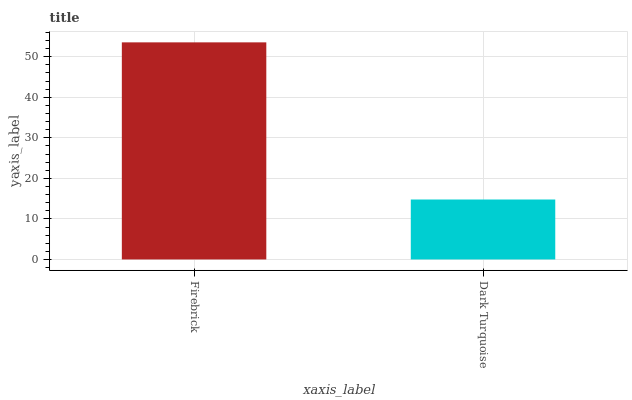Is Dark Turquoise the minimum?
Answer yes or no. Yes. Is Firebrick the maximum?
Answer yes or no. Yes. Is Dark Turquoise the maximum?
Answer yes or no. No. Is Firebrick greater than Dark Turquoise?
Answer yes or no. Yes. Is Dark Turquoise less than Firebrick?
Answer yes or no. Yes. Is Dark Turquoise greater than Firebrick?
Answer yes or no. No. Is Firebrick less than Dark Turquoise?
Answer yes or no. No. Is Firebrick the high median?
Answer yes or no. Yes. Is Dark Turquoise the low median?
Answer yes or no. Yes. Is Dark Turquoise the high median?
Answer yes or no. No. Is Firebrick the low median?
Answer yes or no. No. 